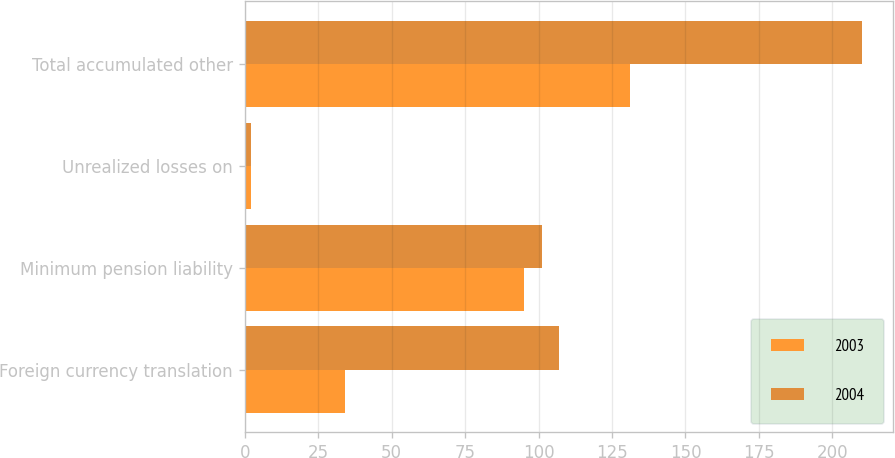Convert chart to OTSL. <chart><loc_0><loc_0><loc_500><loc_500><stacked_bar_chart><ecel><fcel>Foreign currency translation<fcel>Minimum pension liability<fcel>Unrealized losses on<fcel>Total accumulated other<nl><fcel>2003<fcel>34<fcel>95<fcel>2<fcel>131<nl><fcel>2004<fcel>107<fcel>101<fcel>2<fcel>210<nl></chart> 